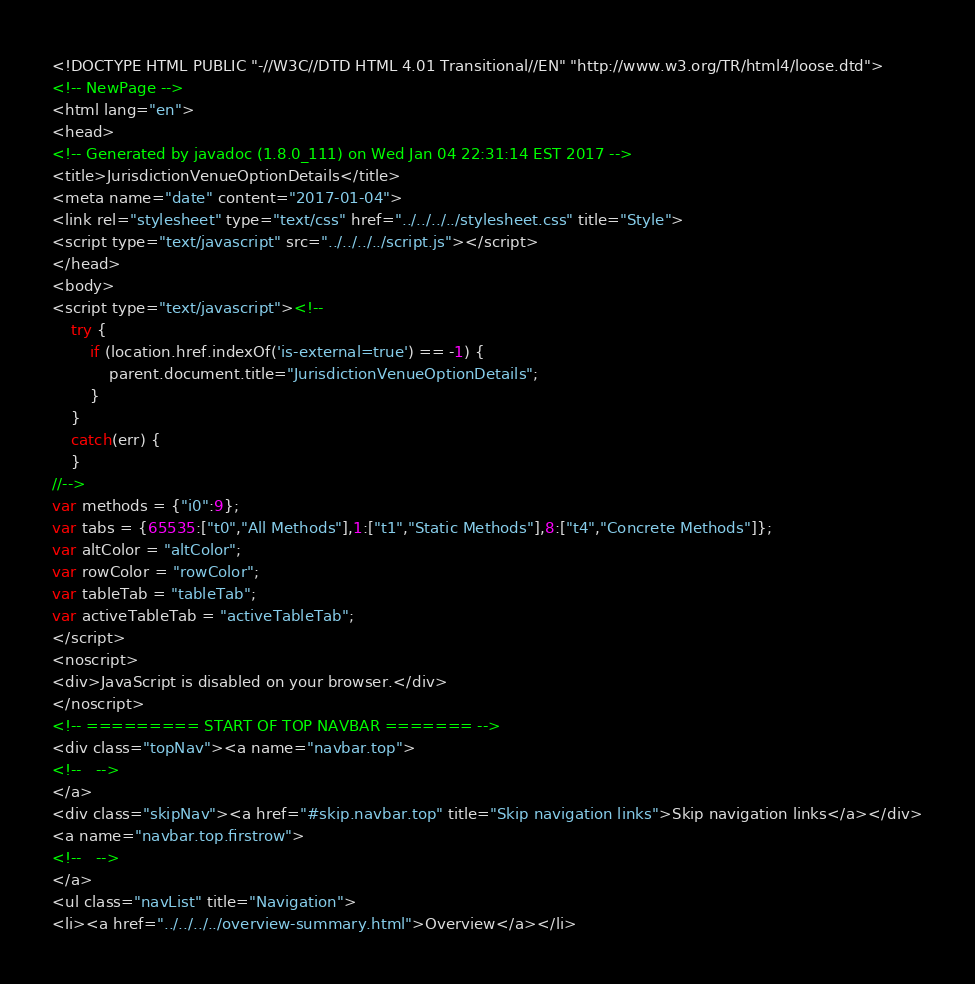Convert code to text. <code><loc_0><loc_0><loc_500><loc_500><_HTML_><!DOCTYPE HTML PUBLIC "-//W3C//DTD HTML 4.01 Transitional//EN" "http://www.w3.org/TR/html4/loose.dtd">
<!-- NewPage -->
<html lang="en">
<head>
<!-- Generated by javadoc (1.8.0_111) on Wed Jan 04 22:31:14 EST 2017 -->
<title>JurisdictionVenueOptionDetails</title>
<meta name="date" content="2017-01-04">
<link rel="stylesheet" type="text/css" href="../../../../stylesheet.css" title="Style">
<script type="text/javascript" src="../../../../script.js"></script>
</head>
<body>
<script type="text/javascript"><!--
    try {
        if (location.href.indexOf('is-external=true') == -1) {
            parent.document.title="JurisdictionVenueOptionDetails";
        }
    }
    catch(err) {
    }
//-->
var methods = {"i0":9};
var tabs = {65535:["t0","All Methods"],1:["t1","Static Methods"],8:["t4","Concrete Methods"]};
var altColor = "altColor";
var rowColor = "rowColor";
var tableTab = "tableTab";
var activeTableTab = "activeTableTab";
</script>
<noscript>
<div>JavaScript is disabled on your browser.</div>
</noscript>
<!-- ========= START OF TOP NAVBAR ======= -->
<div class="topNav"><a name="navbar.top">
<!--   -->
</a>
<div class="skipNav"><a href="#skip.navbar.top" title="Skip navigation links">Skip navigation links</a></div>
<a name="navbar.top.firstrow">
<!--   -->
</a>
<ul class="navList" title="Navigation">
<li><a href="../../../../overview-summary.html">Overview</a></li></code> 